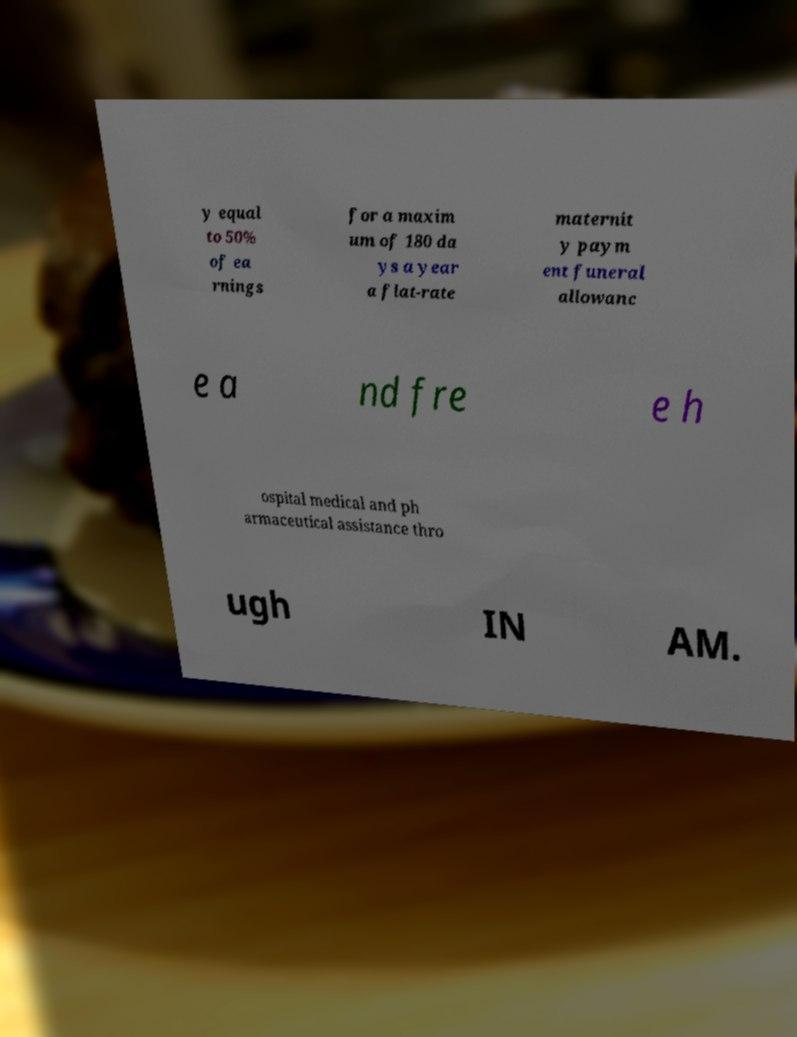Can you read and provide the text displayed in the image?This photo seems to have some interesting text. Can you extract and type it out for me? y equal to 50% of ea rnings for a maxim um of 180 da ys a year a flat-rate maternit y paym ent funeral allowanc e a nd fre e h ospital medical and ph armaceutical assistance thro ugh IN AM. 